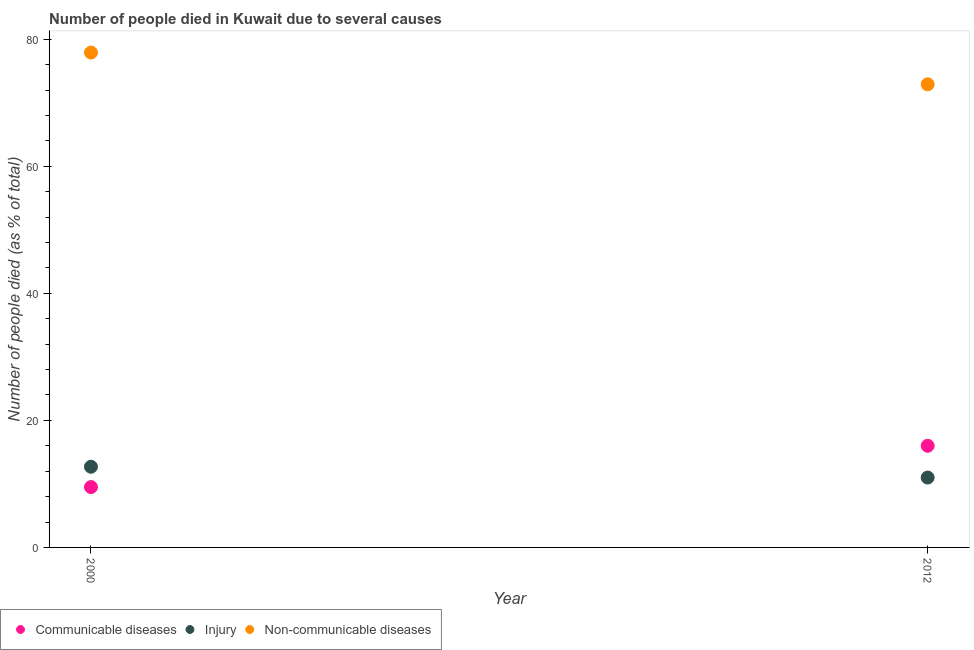How many different coloured dotlines are there?
Your response must be concise. 3. Is the number of dotlines equal to the number of legend labels?
Ensure brevity in your answer.  Yes. What is the number of people who died of injury in 2012?
Ensure brevity in your answer.  11. Across all years, what is the maximum number of people who died of communicable diseases?
Your answer should be very brief. 16. In which year was the number of people who died of communicable diseases maximum?
Offer a very short reply. 2012. In which year was the number of people who died of communicable diseases minimum?
Give a very brief answer. 2000. What is the difference between the number of people who dies of non-communicable diseases in 2012 and the number of people who died of injury in 2000?
Make the answer very short. 60.2. What is the average number of people who dies of non-communicable diseases per year?
Your answer should be compact. 75.4. In the year 2000, what is the difference between the number of people who died of injury and number of people who died of communicable diseases?
Your answer should be compact. 3.2. In how many years, is the number of people who died of injury greater than 40 %?
Your response must be concise. 0. What is the ratio of the number of people who died of communicable diseases in 2000 to that in 2012?
Keep it short and to the point. 0.59. In how many years, is the number of people who died of injury greater than the average number of people who died of injury taken over all years?
Your response must be concise. 1. Does the number of people who died of injury monotonically increase over the years?
Offer a terse response. No. Is the number of people who died of communicable diseases strictly less than the number of people who died of injury over the years?
Provide a short and direct response. No. How many dotlines are there?
Make the answer very short. 3. What is the difference between two consecutive major ticks on the Y-axis?
Keep it short and to the point. 20. Does the graph contain any zero values?
Make the answer very short. No. Where does the legend appear in the graph?
Your response must be concise. Bottom left. What is the title of the graph?
Your answer should be very brief. Number of people died in Kuwait due to several causes. Does "Capital account" appear as one of the legend labels in the graph?
Give a very brief answer. No. What is the label or title of the Y-axis?
Offer a very short reply. Number of people died (as % of total). What is the Number of people died (as % of total) in Communicable diseases in 2000?
Provide a succinct answer. 9.5. What is the Number of people died (as % of total) in Non-communicable diseases in 2000?
Provide a short and direct response. 77.9. What is the Number of people died (as % of total) of Non-communicable diseases in 2012?
Provide a short and direct response. 72.9. Across all years, what is the maximum Number of people died (as % of total) in Injury?
Offer a very short reply. 12.7. Across all years, what is the maximum Number of people died (as % of total) in Non-communicable diseases?
Provide a short and direct response. 77.9. Across all years, what is the minimum Number of people died (as % of total) of Communicable diseases?
Your answer should be very brief. 9.5. Across all years, what is the minimum Number of people died (as % of total) in Non-communicable diseases?
Keep it short and to the point. 72.9. What is the total Number of people died (as % of total) in Injury in the graph?
Ensure brevity in your answer.  23.7. What is the total Number of people died (as % of total) in Non-communicable diseases in the graph?
Ensure brevity in your answer.  150.8. What is the difference between the Number of people died (as % of total) in Communicable diseases in 2000 and that in 2012?
Keep it short and to the point. -6.5. What is the difference between the Number of people died (as % of total) of Non-communicable diseases in 2000 and that in 2012?
Make the answer very short. 5. What is the difference between the Number of people died (as % of total) of Communicable diseases in 2000 and the Number of people died (as % of total) of Non-communicable diseases in 2012?
Give a very brief answer. -63.4. What is the difference between the Number of people died (as % of total) in Injury in 2000 and the Number of people died (as % of total) in Non-communicable diseases in 2012?
Your response must be concise. -60.2. What is the average Number of people died (as % of total) of Communicable diseases per year?
Provide a succinct answer. 12.75. What is the average Number of people died (as % of total) in Injury per year?
Ensure brevity in your answer.  11.85. What is the average Number of people died (as % of total) of Non-communicable diseases per year?
Ensure brevity in your answer.  75.4. In the year 2000, what is the difference between the Number of people died (as % of total) of Communicable diseases and Number of people died (as % of total) of Injury?
Keep it short and to the point. -3.2. In the year 2000, what is the difference between the Number of people died (as % of total) in Communicable diseases and Number of people died (as % of total) in Non-communicable diseases?
Your answer should be compact. -68.4. In the year 2000, what is the difference between the Number of people died (as % of total) of Injury and Number of people died (as % of total) of Non-communicable diseases?
Keep it short and to the point. -65.2. In the year 2012, what is the difference between the Number of people died (as % of total) of Communicable diseases and Number of people died (as % of total) of Non-communicable diseases?
Your answer should be very brief. -56.9. In the year 2012, what is the difference between the Number of people died (as % of total) of Injury and Number of people died (as % of total) of Non-communicable diseases?
Give a very brief answer. -61.9. What is the ratio of the Number of people died (as % of total) of Communicable diseases in 2000 to that in 2012?
Offer a terse response. 0.59. What is the ratio of the Number of people died (as % of total) in Injury in 2000 to that in 2012?
Your response must be concise. 1.15. What is the ratio of the Number of people died (as % of total) of Non-communicable diseases in 2000 to that in 2012?
Give a very brief answer. 1.07. What is the difference between the highest and the second highest Number of people died (as % of total) in Non-communicable diseases?
Your answer should be very brief. 5. What is the difference between the highest and the lowest Number of people died (as % of total) of Non-communicable diseases?
Give a very brief answer. 5. 